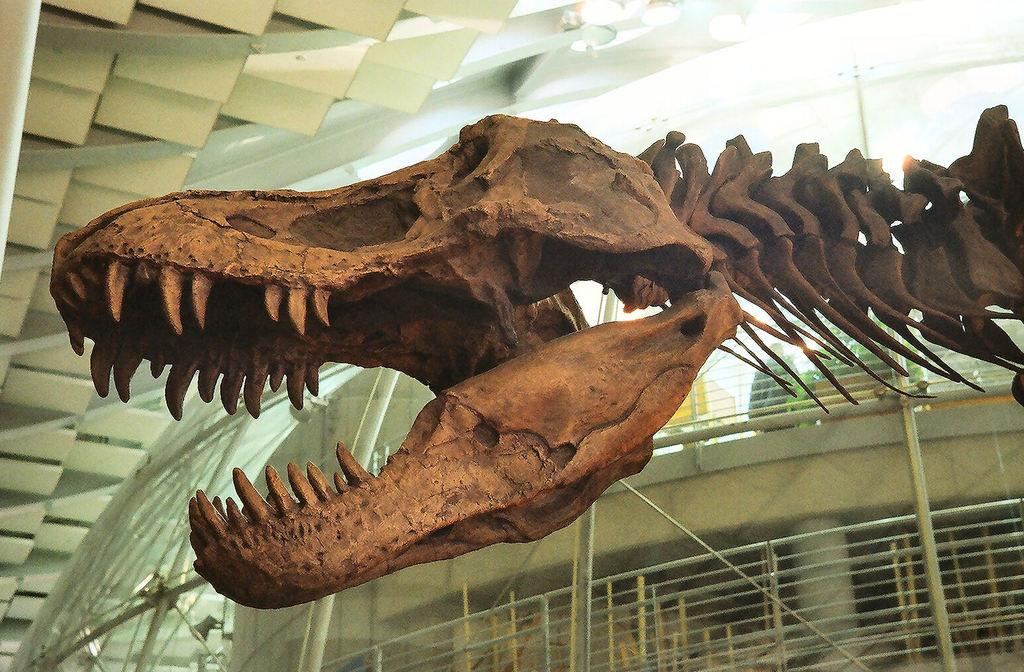What type of animal is in the image? There is an animal in the image, but its specific type cannot be determined from the provided facts. What color is the animal in the image? The animal is brown in color. What can be seen in the background of the image? There are lights and other objects visible in the background of the image. What is the animal's annual income in the image? There is no information about the animal's income in the image, as animals do not have incomes. 